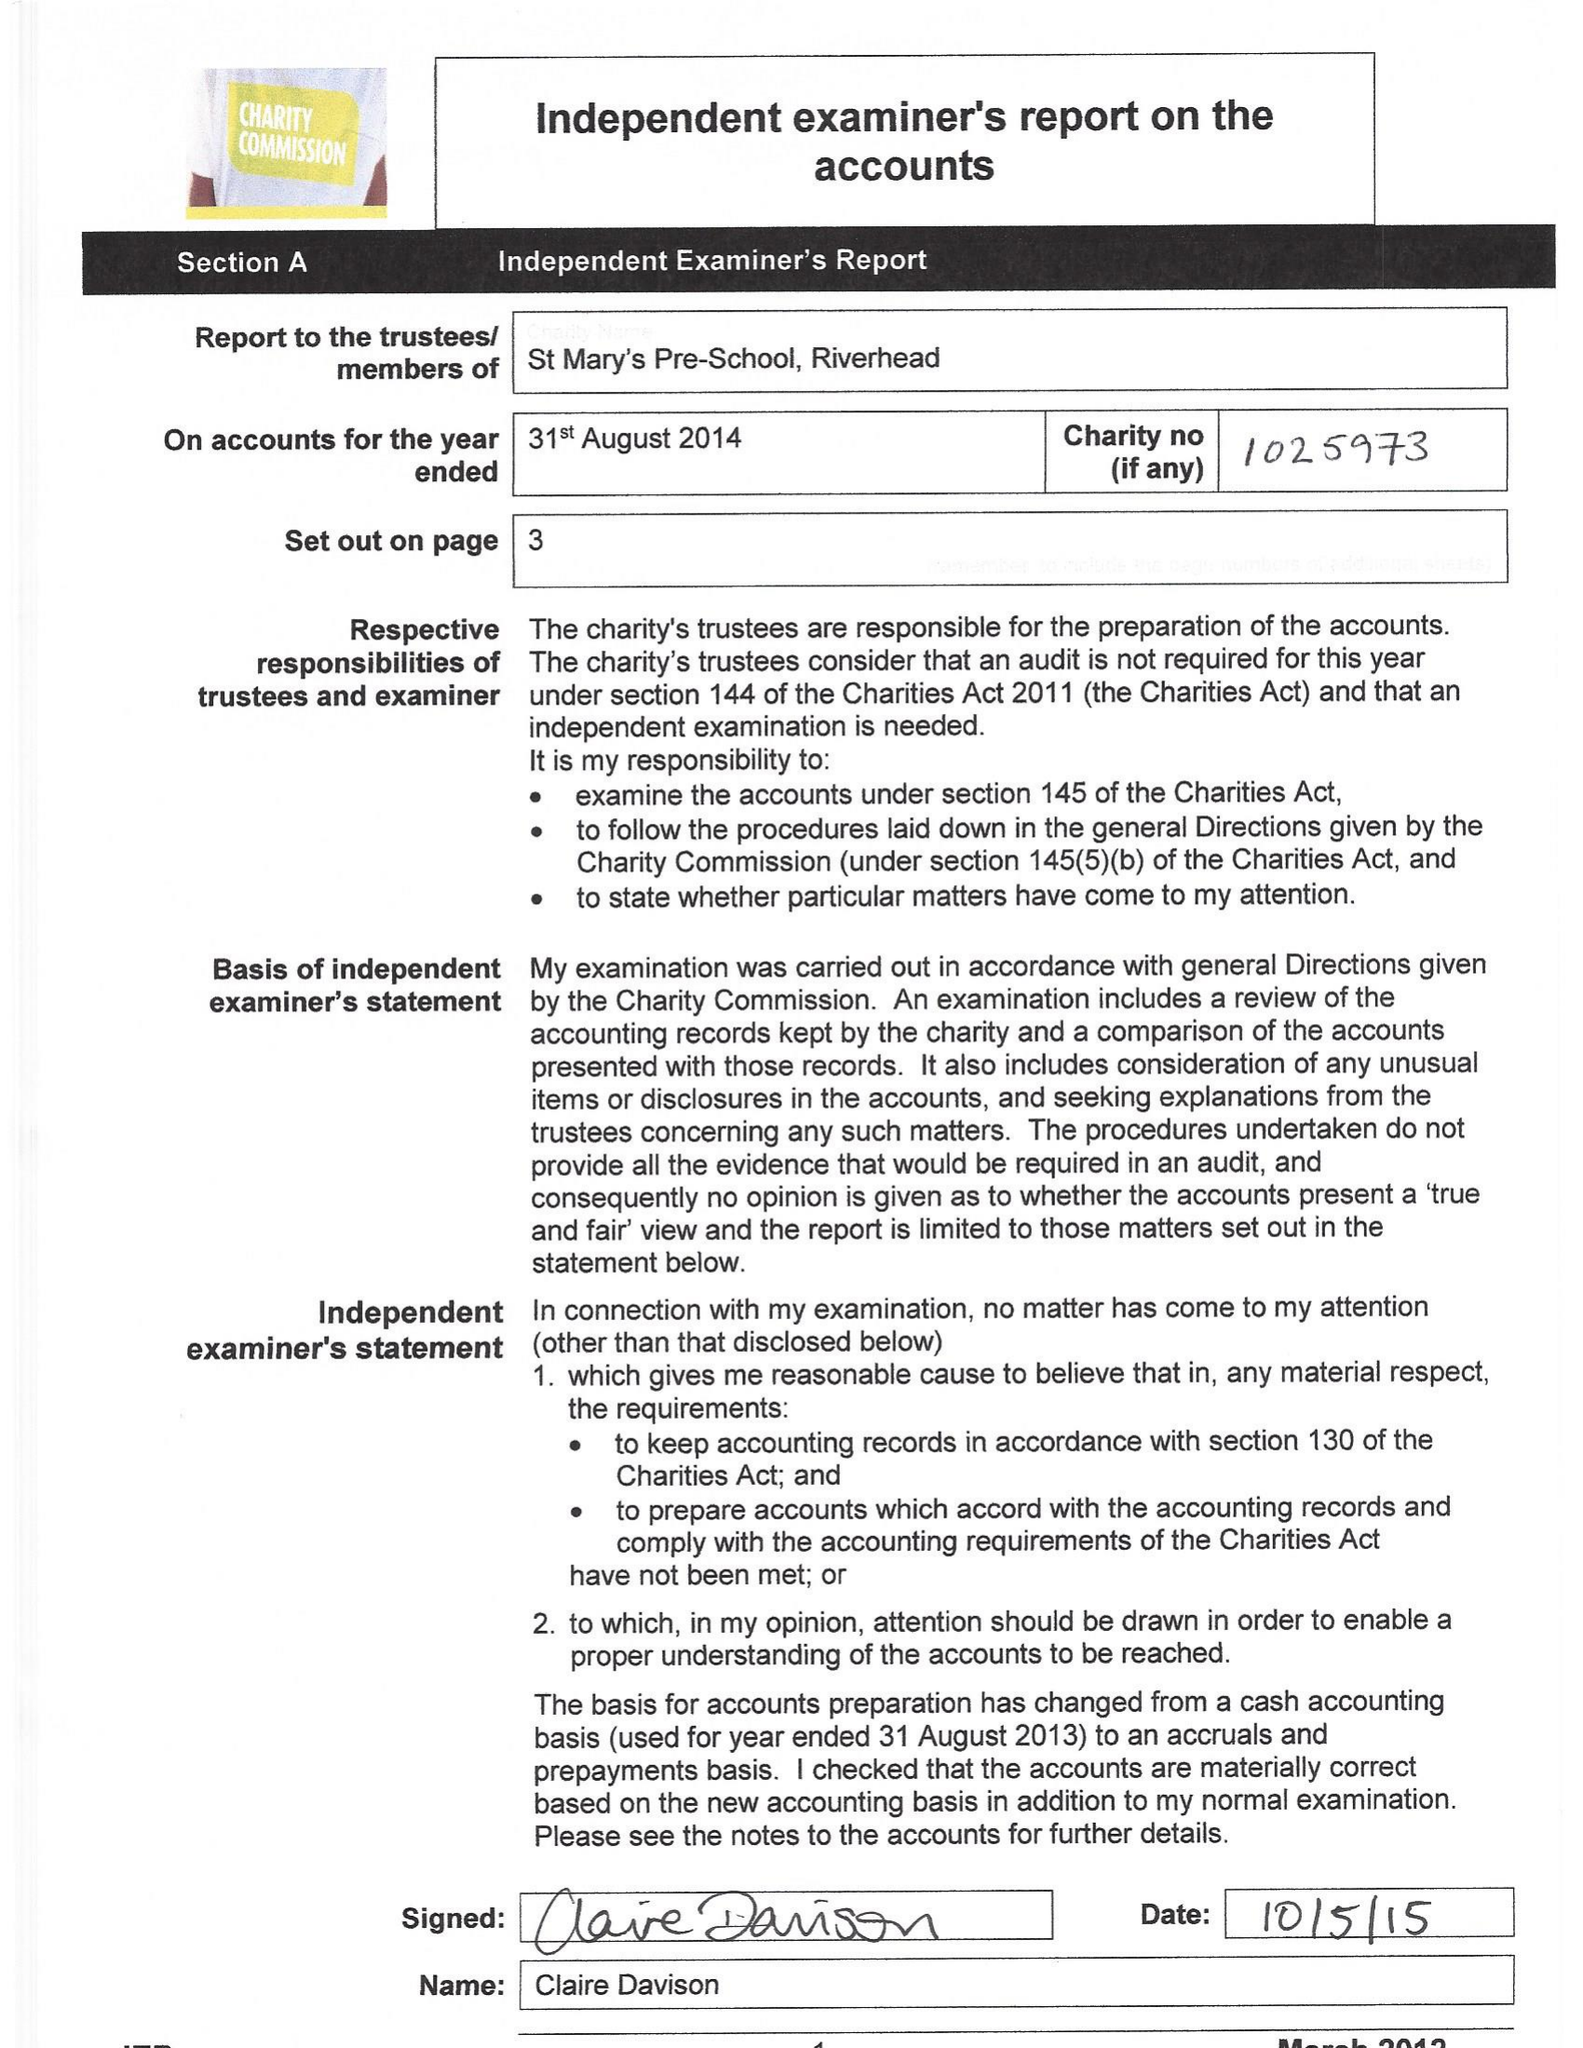What is the value for the report_date?
Answer the question using a single word or phrase. 2014-08-31 